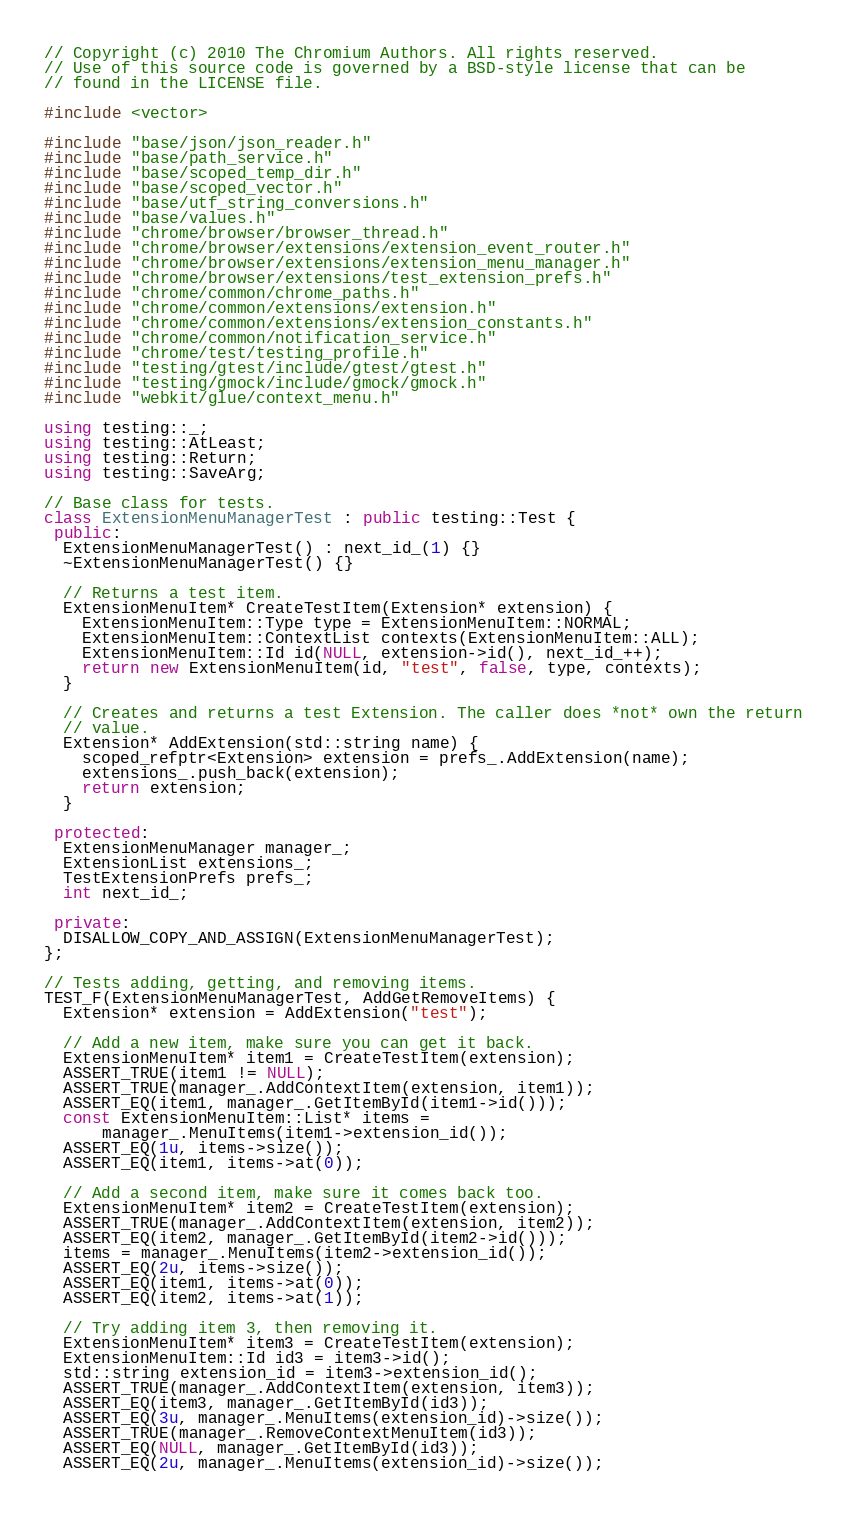Convert code to text. <code><loc_0><loc_0><loc_500><loc_500><_C++_>// Copyright (c) 2010 The Chromium Authors. All rights reserved.
// Use of this source code is governed by a BSD-style license that can be
// found in the LICENSE file.

#include <vector>

#include "base/json/json_reader.h"
#include "base/path_service.h"
#include "base/scoped_temp_dir.h"
#include "base/scoped_vector.h"
#include "base/utf_string_conversions.h"
#include "base/values.h"
#include "chrome/browser/browser_thread.h"
#include "chrome/browser/extensions/extension_event_router.h"
#include "chrome/browser/extensions/extension_menu_manager.h"
#include "chrome/browser/extensions/test_extension_prefs.h"
#include "chrome/common/chrome_paths.h"
#include "chrome/common/extensions/extension.h"
#include "chrome/common/extensions/extension_constants.h"
#include "chrome/common/notification_service.h"
#include "chrome/test/testing_profile.h"
#include "testing/gtest/include/gtest/gtest.h"
#include "testing/gmock/include/gmock/gmock.h"
#include "webkit/glue/context_menu.h"

using testing::_;
using testing::AtLeast;
using testing::Return;
using testing::SaveArg;

// Base class for tests.
class ExtensionMenuManagerTest : public testing::Test {
 public:
  ExtensionMenuManagerTest() : next_id_(1) {}
  ~ExtensionMenuManagerTest() {}

  // Returns a test item.
  ExtensionMenuItem* CreateTestItem(Extension* extension) {
    ExtensionMenuItem::Type type = ExtensionMenuItem::NORMAL;
    ExtensionMenuItem::ContextList contexts(ExtensionMenuItem::ALL);
    ExtensionMenuItem::Id id(NULL, extension->id(), next_id_++);
    return new ExtensionMenuItem(id, "test", false, type, contexts);
  }

  // Creates and returns a test Extension. The caller does *not* own the return
  // value.
  Extension* AddExtension(std::string name) {
    scoped_refptr<Extension> extension = prefs_.AddExtension(name);
    extensions_.push_back(extension);
    return extension;
  }

 protected:
  ExtensionMenuManager manager_;
  ExtensionList extensions_;
  TestExtensionPrefs prefs_;
  int next_id_;

 private:
  DISALLOW_COPY_AND_ASSIGN(ExtensionMenuManagerTest);
};

// Tests adding, getting, and removing items.
TEST_F(ExtensionMenuManagerTest, AddGetRemoveItems) {
  Extension* extension = AddExtension("test");

  // Add a new item, make sure you can get it back.
  ExtensionMenuItem* item1 = CreateTestItem(extension);
  ASSERT_TRUE(item1 != NULL);
  ASSERT_TRUE(manager_.AddContextItem(extension, item1));
  ASSERT_EQ(item1, manager_.GetItemById(item1->id()));
  const ExtensionMenuItem::List* items =
      manager_.MenuItems(item1->extension_id());
  ASSERT_EQ(1u, items->size());
  ASSERT_EQ(item1, items->at(0));

  // Add a second item, make sure it comes back too.
  ExtensionMenuItem* item2 = CreateTestItem(extension);
  ASSERT_TRUE(manager_.AddContextItem(extension, item2));
  ASSERT_EQ(item2, manager_.GetItemById(item2->id()));
  items = manager_.MenuItems(item2->extension_id());
  ASSERT_EQ(2u, items->size());
  ASSERT_EQ(item1, items->at(0));
  ASSERT_EQ(item2, items->at(1));

  // Try adding item 3, then removing it.
  ExtensionMenuItem* item3 = CreateTestItem(extension);
  ExtensionMenuItem::Id id3 = item3->id();
  std::string extension_id = item3->extension_id();
  ASSERT_TRUE(manager_.AddContextItem(extension, item3));
  ASSERT_EQ(item3, manager_.GetItemById(id3));
  ASSERT_EQ(3u, manager_.MenuItems(extension_id)->size());
  ASSERT_TRUE(manager_.RemoveContextMenuItem(id3));
  ASSERT_EQ(NULL, manager_.GetItemById(id3));
  ASSERT_EQ(2u, manager_.MenuItems(extension_id)->size());
</code> 